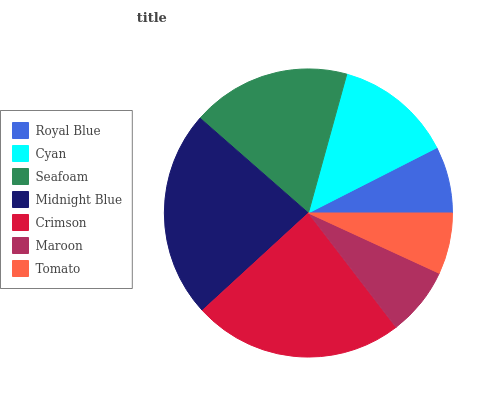Is Tomato the minimum?
Answer yes or no. Yes. Is Crimson the maximum?
Answer yes or no. Yes. Is Cyan the minimum?
Answer yes or no. No. Is Cyan the maximum?
Answer yes or no. No. Is Cyan greater than Royal Blue?
Answer yes or no. Yes. Is Royal Blue less than Cyan?
Answer yes or no. Yes. Is Royal Blue greater than Cyan?
Answer yes or no. No. Is Cyan less than Royal Blue?
Answer yes or no. No. Is Cyan the high median?
Answer yes or no. Yes. Is Cyan the low median?
Answer yes or no. Yes. Is Royal Blue the high median?
Answer yes or no. No. Is Crimson the low median?
Answer yes or no. No. 